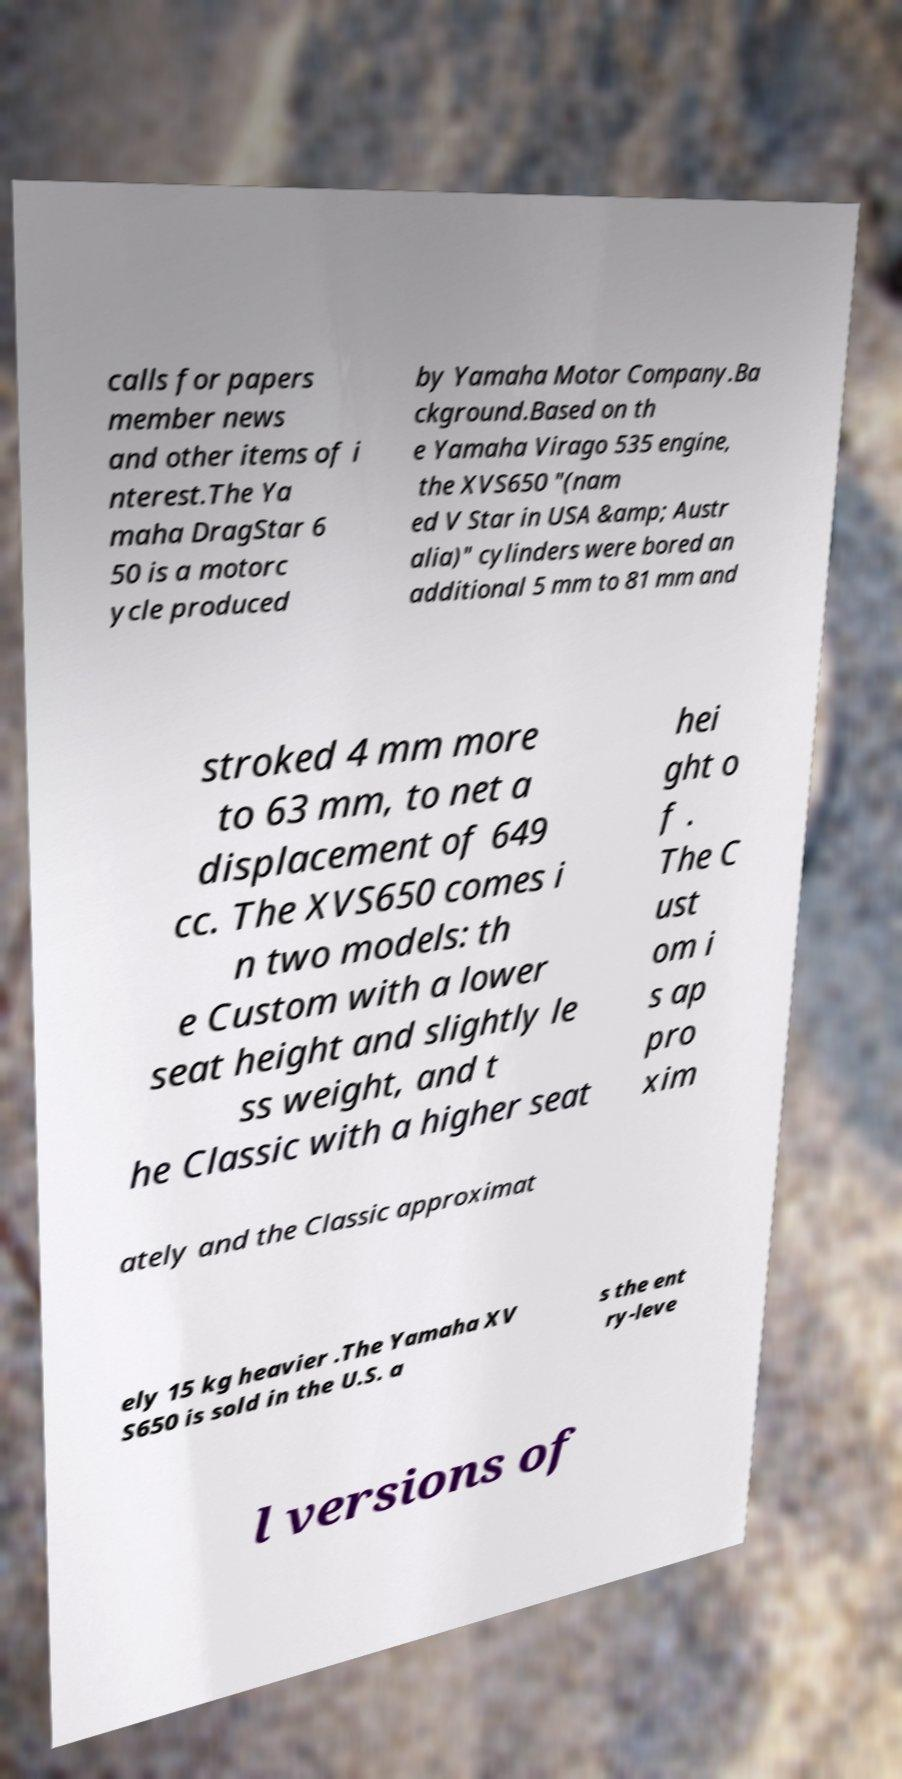Could you assist in decoding the text presented in this image and type it out clearly? calls for papers member news and other items of i nterest.The Ya maha DragStar 6 50 is a motorc ycle produced by Yamaha Motor Company.Ba ckground.Based on th e Yamaha Virago 535 engine, the XVS650 "(nam ed V Star in USA &amp; Austr alia)" cylinders were bored an additional 5 mm to 81 mm and stroked 4 mm more to 63 mm, to net a displacement of 649 cc. The XVS650 comes i n two models: th e Custom with a lower seat height and slightly le ss weight, and t he Classic with a higher seat hei ght o f . The C ust om i s ap pro xim ately and the Classic approximat ely 15 kg heavier .The Yamaha XV S650 is sold in the U.S. a s the ent ry-leve l versions of 